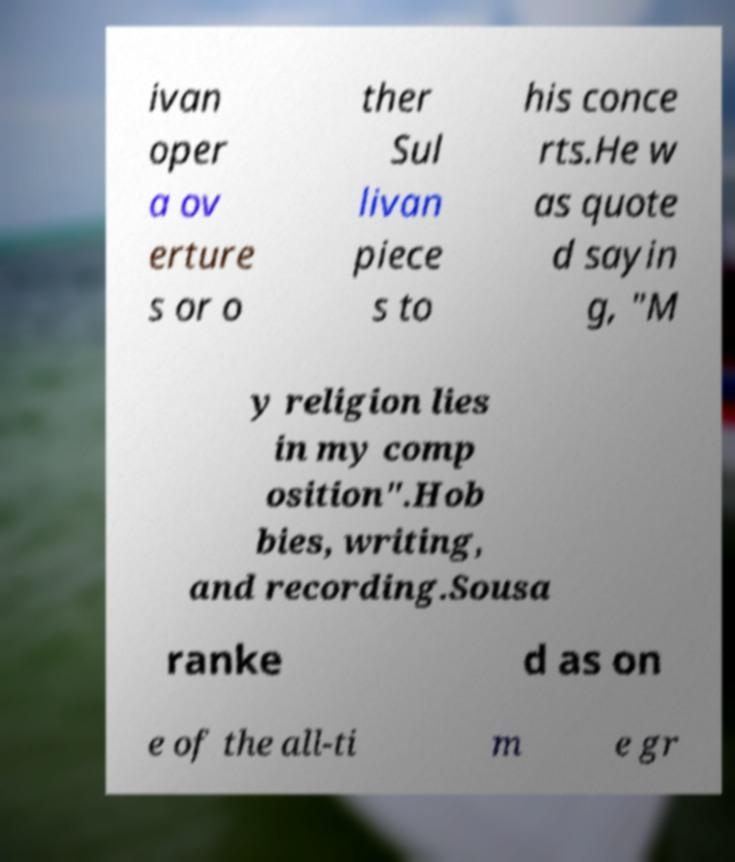Please identify and transcribe the text found in this image. ivan oper a ov erture s or o ther Sul livan piece s to his conce rts.He w as quote d sayin g, "M y religion lies in my comp osition".Hob bies, writing, and recording.Sousa ranke d as on e of the all-ti m e gr 